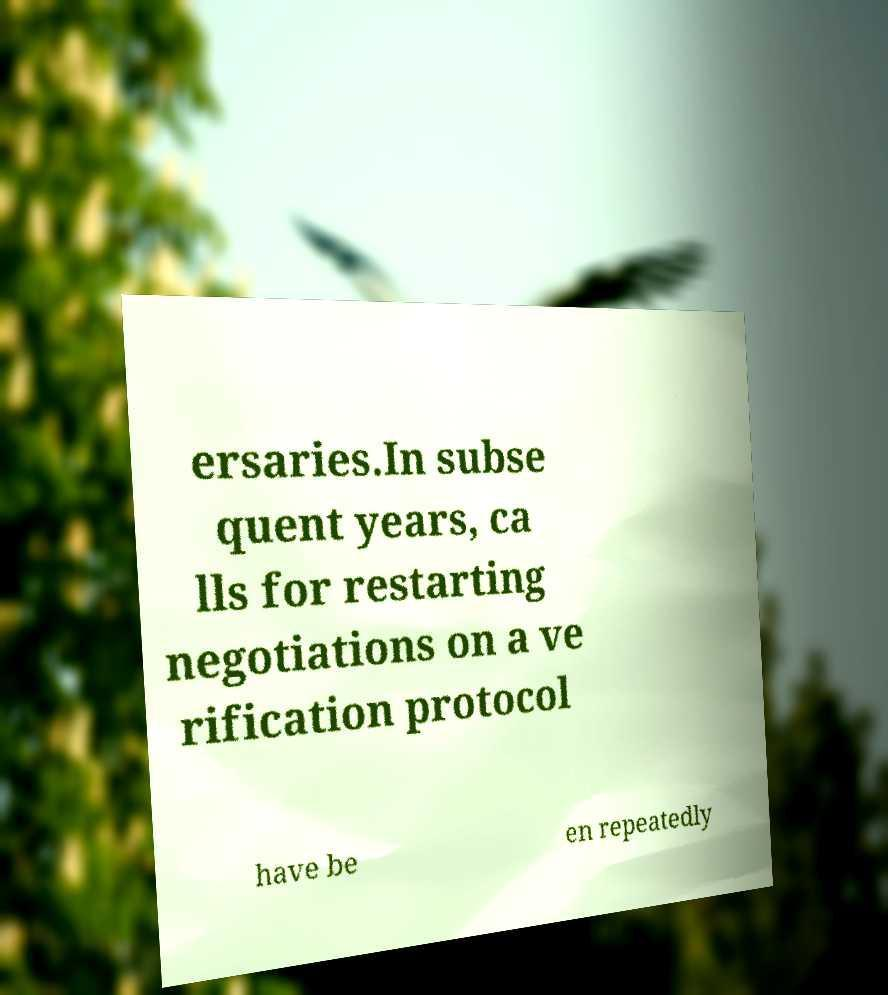I need the written content from this picture converted into text. Can you do that? ersaries.In subse quent years, ca lls for restarting negotiations on a ve rification protocol have be en repeatedly 